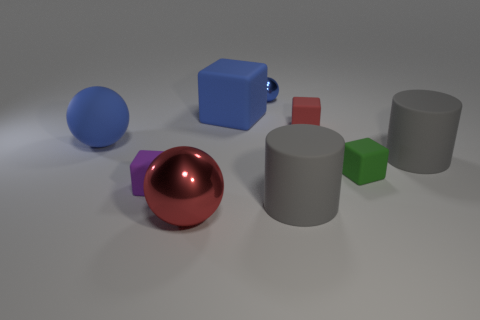Subtract all purple blocks. How many blocks are left? 3 Subtract 1 blocks. How many blocks are left? 3 Subtract all cyan blocks. Subtract all gray balls. How many blocks are left? 4 Subtract all cubes. How many objects are left? 5 Subtract all big cubes. Subtract all large blue spheres. How many objects are left? 7 Add 7 large red things. How many large red things are left? 8 Add 4 small green matte cubes. How many small green matte cubes exist? 5 Subtract 1 red balls. How many objects are left? 8 